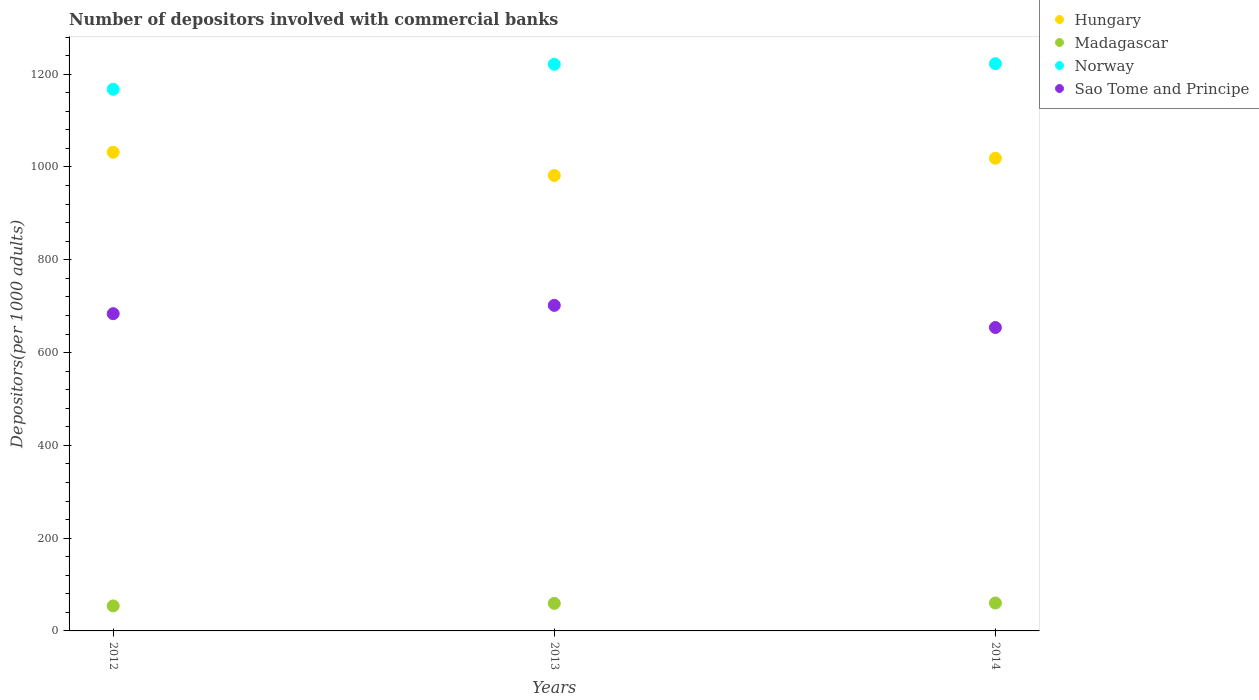How many different coloured dotlines are there?
Your response must be concise. 4. What is the number of depositors involved with commercial banks in Sao Tome and Principe in 2012?
Make the answer very short. 683.81. Across all years, what is the maximum number of depositors involved with commercial banks in Hungary?
Ensure brevity in your answer.  1031.82. Across all years, what is the minimum number of depositors involved with commercial banks in Norway?
Give a very brief answer. 1167.46. In which year was the number of depositors involved with commercial banks in Sao Tome and Principe minimum?
Your answer should be very brief. 2014. What is the total number of depositors involved with commercial banks in Sao Tome and Principe in the graph?
Make the answer very short. 2039.51. What is the difference between the number of depositors involved with commercial banks in Madagascar in 2012 and that in 2013?
Provide a succinct answer. -5.46. What is the difference between the number of depositors involved with commercial banks in Sao Tome and Principe in 2013 and the number of depositors involved with commercial banks in Norway in 2012?
Provide a succinct answer. -465.77. What is the average number of depositors involved with commercial banks in Madagascar per year?
Your answer should be compact. 57.83. In the year 2013, what is the difference between the number of depositors involved with commercial banks in Sao Tome and Principe and number of depositors involved with commercial banks in Hungary?
Provide a short and direct response. -279.97. What is the ratio of the number of depositors involved with commercial banks in Hungary in 2012 to that in 2014?
Your response must be concise. 1.01. Is the number of depositors involved with commercial banks in Sao Tome and Principe in 2012 less than that in 2013?
Provide a succinct answer. Yes. Is the difference between the number of depositors involved with commercial banks in Sao Tome and Principe in 2013 and 2014 greater than the difference between the number of depositors involved with commercial banks in Hungary in 2013 and 2014?
Offer a terse response. Yes. What is the difference between the highest and the second highest number of depositors involved with commercial banks in Sao Tome and Principe?
Give a very brief answer. 17.89. What is the difference between the highest and the lowest number of depositors involved with commercial banks in Hungary?
Your answer should be very brief. 50.15. Is it the case that in every year, the sum of the number of depositors involved with commercial banks in Norway and number of depositors involved with commercial banks in Hungary  is greater than the number of depositors involved with commercial banks in Madagascar?
Your answer should be very brief. Yes. Does the number of depositors involved with commercial banks in Madagascar monotonically increase over the years?
Your answer should be compact. Yes. Is the number of depositors involved with commercial banks in Madagascar strictly less than the number of depositors involved with commercial banks in Norway over the years?
Your response must be concise. Yes. How many dotlines are there?
Provide a short and direct response. 4. What is the difference between two consecutive major ticks on the Y-axis?
Ensure brevity in your answer.  200. Are the values on the major ticks of Y-axis written in scientific E-notation?
Your answer should be very brief. No. Where does the legend appear in the graph?
Make the answer very short. Top right. How many legend labels are there?
Your answer should be compact. 4. What is the title of the graph?
Your answer should be compact. Number of depositors involved with commercial banks. Does "Swaziland" appear as one of the legend labels in the graph?
Provide a short and direct response. No. What is the label or title of the Y-axis?
Provide a succinct answer. Depositors(per 1000 adults). What is the Depositors(per 1000 adults) of Hungary in 2012?
Make the answer very short. 1031.82. What is the Depositors(per 1000 adults) of Madagascar in 2012?
Offer a very short reply. 53.92. What is the Depositors(per 1000 adults) in Norway in 2012?
Provide a succinct answer. 1167.46. What is the Depositors(per 1000 adults) in Sao Tome and Principe in 2012?
Provide a succinct answer. 683.81. What is the Depositors(per 1000 adults) of Hungary in 2013?
Keep it short and to the point. 981.67. What is the Depositors(per 1000 adults) in Madagascar in 2013?
Your response must be concise. 59.38. What is the Depositors(per 1000 adults) of Norway in 2013?
Provide a short and direct response. 1221.4. What is the Depositors(per 1000 adults) in Sao Tome and Principe in 2013?
Make the answer very short. 701.7. What is the Depositors(per 1000 adults) of Hungary in 2014?
Keep it short and to the point. 1018.74. What is the Depositors(per 1000 adults) of Madagascar in 2014?
Make the answer very short. 60.19. What is the Depositors(per 1000 adults) of Norway in 2014?
Your answer should be very brief. 1222.66. What is the Depositors(per 1000 adults) in Sao Tome and Principe in 2014?
Your response must be concise. 654. Across all years, what is the maximum Depositors(per 1000 adults) of Hungary?
Offer a terse response. 1031.82. Across all years, what is the maximum Depositors(per 1000 adults) in Madagascar?
Provide a succinct answer. 60.19. Across all years, what is the maximum Depositors(per 1000 adults) in Norway?
Ensure brevity in your answer.  1222.66. Across all years, what is the maximum Depositors(per 1000 adults) in Sao Tome and Principe?
Your answer should be compact. 701.7. Across all years, what is the minimum Depositors(per 1000 adults) in Hungary?
Provide a short and direct response. 981.67. Across all years, what is the minimum Depositors(per 1000 adults) of Madagascar?
Offer a very short reply. 53.92. Across all years, what is the minimum Depositors(per 1000 adults) in Norway?
Your answer should be very brief. 1167.46. Across all years, what is the minimum Depositors(per 1000 adults) in Sao Tome and Principe?
Ensure brevity in your answer.  654. What is the total Depositors(per 1000 adults) in Hungary in the graph?
Offer a terse response. 3032.23. What is the total Depositors(per 1000 adults) of Madagascar in the graph?
Your answer should be compact. 173.48. What is the total Depositors(per 1000 adults) of Norway in the graph?
Your answer should be compact. 3611.53. What is the total Depositors(per 1000 adults) in Sao Tome and Principe in the graph?
Provide a succinct answer. 2039.51. What is the difference between the Depositors(per 1000 adults) of Hungary in 2012 and that in 2013?
Give a very brief answer. 50.15. What is the difference between the Depositors(per 1000 adults) of Madagascar in 2012 and that in 2013?
Your answer should be very brief. -5.46. What is the difference between the Depositors(per 1000 adults) of Norway in 2012 and that in 2013?
Your response must be concise. -53.94. What is the difference between the Depositors(per 1000 adults) in Sao Tome and Principe in 2012 and that in 2013?
Your response must be concise. -17.89. What is the difference between the Depositors(per 1000 adults) in Hungary in 2012 and that in 2014?
Provide a succinct answer. 13.07. What is the difference between the Depositors(per 1000 adults) of Madagascar in 2012 and that in 2014?
Give a very brief answer. -6.27. What is the difference between the Depositors(per 1000 adults) in Norway in 2012 and that in 2014?
Give a very brief answer. -55.2. What is the difference between the Depositors(per 1000 adults) in Sao Tome and Principe in 2012 and that in 2014?
Your answer should be compact. 29.82. What is the difference between the Depositors(per 1000 adults) of Hungary in 2013 and that in 2014?
Give a very brief answer. -37.07. What is the difference between the Depositors(per 1000 adults) in Madagascar in 2013 and that in 2014?
Ensure brevity in your answer.  -0.81. What is the difference between the Depositors(per 1000 adults) in Norway in 2013 and that in 2014?
Provide a succinct answer. -1.26. What is the difference between the Depositors(per 1000 adults) in Sao Tome and Principe in 2013 and that in 2014?
Offer a terse response. 47.7. What is the difference between the Depositors(per 1000 adults) in Hungary in 2012 and the Depositors(per 1000 adults) in Madagascar in 2013?
Offer a very short reply. 972.44. What is the difference between the Depositors(per 1000 adults) of Hungary in 2012 and the Depositors(per 1000 adults) of Norway in 2013?
Provide a succinct answer. -189.59. What is the difference between the Depositors(per 1000 adults) of Hungary in 2012 and the Depositors(per 1000 adults) of Sao Tome and Principe in 2013?
Provide a succinct answer. 330.12. What is the difference between the Depositors(per 1000 adults) in Madagascar in 2012 and the Depositors(per 1000 adults) in Norway in 2013?
Provide a succinct answer. -1167.48. What is the difference between the Depositors(per 1000 adults) of Madagascar in 2012 and the Depositors(per 1000 adults) of Sao Tome and Principe in 2013?
Your answer should be compact. -647.78. What is the difference between the Depositors(per 1000 adults) of Norway in 2012 and the Depositors(per 1000 adults) of Sao Tome and Principe in 2013?
Your answer should be compact. 465.77. What is the difference between the Depositors(per 1000 adults) in Hungary in 2012 and the Depositors(per 1000 adults) in Madagascar in 2014?
Make the answer very short. 971.63. What is the difference between the Depositors(per 1000 adults) of Hungary in 2012 and the Depositors(per 1000 adults) of Norway in 2014?
Your answer should be very brief. -190.85. What is the difference between the Depositors(per 1000 adults) of Hungary in 2012 and the Depositors(per 1000 adults) of Sao Tome and Principe in 2014?
Offer a very short reply. 377.82. What is the difference between the Depositors(per 1000 adults) in Madagascar in 2012 and the Depositors(per 1000 adults) in Norway in 2014?
Make the answer very short. -1168.74. What is the difference between the Depositors(per 1000 adults) in Madagascar in 2012 and the Depositors(per 1000 adults) in Sao Tome and Principe in 2014?
Your answer should be very brief. -600.08. What is the difference between the Depositors(per 1000 adults) in Norway in 2012 and the Depositors(per 1000 adults) in Sao Tome and Principe in 2014?
Give a very brief answer. 513.47. What is the difference between the Depositors(per 1000 adults) in Hungary in 2013 and the Depositors(per 1000 adults) in Madagascar in 2014?
Provide a short and direct response. 921.48. What is the difference between the Depositors(per 1000 adults) of Hungary in 2013 and the Depositors(per 1000 adults) of Norway in 2014?
Offer a very short reply. -240.99. What is the difference between the Depositors(per 1000 adults) of Hungary in 2013 and the Depositors(per 1000 adults) of Sao Tome and Principe in 2014?
Offer a terse response. 327.67. What is the difference between the Depositors(per 1000 adults) of Madagascar in 2013 and the Depositors(per 1000 adults) of Norway in 2014?
Your answer should be very brief. -1163.28. What is the difference between the Depositors(per 1000 adults) in Madagascar in 2013 and the Depositors(per 1000 adults) in Sao Tome and Principe in 2014?
Make the answer very short. -594.62. What is the difference between the Depositors(per 1000 adults) of Norway in 2013 and the Depositors(per 1000 adults) of Sao Tome and Principe in 2014?
Offer a terse response. 567.41. What is the average Depositors(per 1000 adults) in Hungary per year?
Your answer should be very brief. 1010.74. What is the average Depositors(per 1000 adults) in Madagascar per year?
Provide a short and direct response. 57.83. What is the average Depositors(per 1000 adults) in Norway per year?
Your answer should be compact. 1203.84. What is the average Depositors(per 1000 adults) in Sao Tome and Principe per year?
Keep it short and to the point. 679.84. In the year 2012, what is the difference between the Depositors(per 1000 adults) of Hungary and Depositors(per 1000 adults) of Madagascar?
Keep it short and to the point. 977.9. In the year 2012, what is the difference between the Depositors(per 1000 adults) of Hungary and Depositors(per 1000 adults) of Norway?
Provide a short and direct response. -135.65. In the year 2012, what is the difference between the Depositors(per 1000 adults) of Hungary and Depositors(per 1000 adults) of Sao Tome and Principe?
Keep it short and to the point. 348. In the year 2012, what is the difference between the Depositors(per 1000 adults) in Madagascar and Depositors(per 1000 adults) in Norway?
Provide a succinct answer. -1113.55. In the year 2012, what is the difference between the Depositors(per 1000 adults) of Madagascar and Depositors(per 1000 adults) of Sao Tome and Principe?
Ensure brevity in your answer.  -629.89. In the year 2012, what is the difference between the Depositors(per 1000 adults) of Norway and Depositors(per 1000 adults) of Sao Tome and Principe?
Keep it short and to the point. 483.65. In the year 2013, what is the difference between the Depositors(per 1000 adults) of Hungary and Depositors(per 1000 adults) of Madagascar?
Your answer should be very brief. 922.29. In the year 2013, what is the difference between the Depositors(per 1000 adults) in Hungary and Depositors(per 1000 adults) in Norway?
Your answer should be compact. -239.73. In the year 2013, what is the difference between the Depositors(per 1000 adults) in Hungary and Depositors(per 1000 adults) in Sao Tome and Principe?
Give a very brief answer. 279.97. In the year 2013, what is the difference between the Depositors(per 1000 adults) in Madagascar and Depositors(per 1000 adults) in Norway?
Provide a succinct answer. -1162.02. In the year 2013, what is the difference between the Depositors(per 1000 adults) of Madagascar and Depositors(per 1000 adults) of Sao Tome and Principe?
Your response must be concise. -642.32. In the year 2013, what is the difference between the Depositors(per 1000 adults) of Norway and Depositors(per 1000 adults) of Sao Tome and Principe?
Keep it short and to the point. 519.71. In the year 2014, what is the difference between the Depositors(per 1000 adults) in Hungary and Depositors(per 1000 adults) in Madagascar?
Make the answer very short. 958.56. In the year 2014, what is the difference between the Depositors(per 1000 adults) of Hungary and Depositors(per 1000 adults) of Norway?
Make the answer very short. -203.92. In the year 2014, what is the difference between the Depositors(per 1000 adults) of Hungary and Depositors(per 1000 adults) of Sao Tome and Principe?
Your response must be concise. 364.75. In the year 2014, what is the difference between the Depositors(per 1000 adults) in Madagascar and Depositors(per 1000 adults) in Norway?
Your response must be concise. -1162.47. In the year 2014, what is the difference between the Depositors(per 1000 adults) of Madagascar and Depositors(per 1000 adults) of Sao Tome and Principe?
Give a very brief answer. -593.81. In the year 2014, what is the difference between the Depositors(per 1000 adults) in Norway and Depositors(per 1000 adults) in Sao Tome and Principe?
Provide a short and direct response. 568.66. What is the ratio of the Depositors(per 1000 adults) of Hungary in 2012 to that in 2013?
Your response must be concise. 1.05. What is the ratio of the Depositors(per 1000 adults) in Madagascar in 2012 to that in 2013?
Offer a terse response. 0.91. What is the ratio of the Depositors(per 1000 adults) in Norway in 2012 to that in 2013?
Your answer should be very brief. 0.96. What is the ratio of the Depositors(per 1000 adults) of Sao Tome and Principe in 2012 to that in 2013?
Your answer should be very brief. 0.97. What is the ratio of the Depositors(per 1000 adults) in Hungary in 2012 to that in 2014?
Provide a short and direct response. 1.01. What is the ratio of the Depositors(per 1000 adults) of Madagascar in 2012 to that in 2014?
Provide a succinct answer. 0.9. What is the ratio of the Depositors(per 1000 adults) in Norway in 2012 to that in 2014?
Give a very brief answer. 0.95. What is the ratio of the Depositors(per 1000 adults) in Sao Tome and Principe in 2012 to that in 2014?
Your answer should be compact. 1.05. What is the ratio of the Depositors(per 1000 adults) of Hungary in 2013 to that in 2014?
Make the answer very short. 0.96. What is the ratio of the Depositors(per 1000 adults) of Madagascar in 2013 to that in 2014?
Provide a short and direct response. 0.99. What is the ratio of the Depositors(per 1000 adults) of Sao Tome and Principe in 2013 to that in 2014?
Keep it short and to the point. 1.07. What is the difference between the highest and the second highest Depositors(per 1000 adults) in Hungary?
Keep it short and to the point. 13.07. What is the difference between the highest and the second highest Depositors(per 1000 adults) in Madagascar?
Your response must be concise. 0.81. What is the difference between the highest and the second highest Depositors(per 1000 adults) in Norway?
Offer a very short reply. 1.26. What is the difference between the highest and the second highest Depositors(per 1000 adults) in Sao Tome and Principe?
Ensure brevity in your answer.  17.89. What is the difference between the highest and the lowest Depositors(per 1000 adults) in Hungary?
Your response must be concise. 50.15. What is the difference between the highest and the lowest Depositors(per 1000 adults) of Madagascar?
Offer a terse response. 6.27. What is the difference between the highest and the lowest Depositors(per 1000 adults) of Norway?
Provide a short and direct response. 55.2. What is the difference between the highest and the lowest Depositors(per 1000 adults) in Sao Tome and Principe?
Your answer should be very brief. 47.7. 